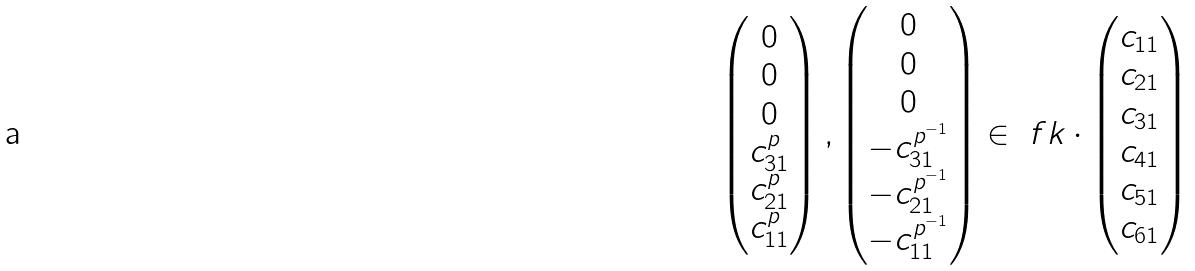<formula> <loc_0><loc_0><loc_500><loc_500>\begin{pmatrix} 0 \\ 0 \\ 0 \\ c _ { 3 1 } ^ { p } \\ c _ { 2 1 } ^ { p } \\ c _ { 1 1 } ^ { p } \end{pmatrix} , \begin{pmatrix} 0 \\ 0 \\ 0 \\ - c _ { 3 1 } ^ { p ^ { - 1 } } \\ - c _ { 2 1 } ^ { p ^ { - 1 } } \\ - c _ { 1 1 } ^ { p ^ { - 1 } } \end{pmatrix} \in \ f k \cdot \begin{pmatrix} c _ { 1 1 } \\ c _ { 2 1 } \\ c _ { 3 1 } \\ c _ { 4 1 } \\ c _ { 5 1 } \\ c _ { 6 1 } \end{pmatrix}</formula> 